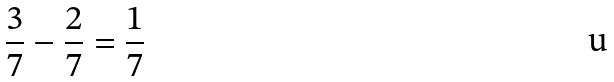<formula> <loc_0><loc_0><loc_500><loc_500>\frac { 3 } { 7 } - \frac { 2 } { 7 } = \frac { 1 } { 7 }</formula> 